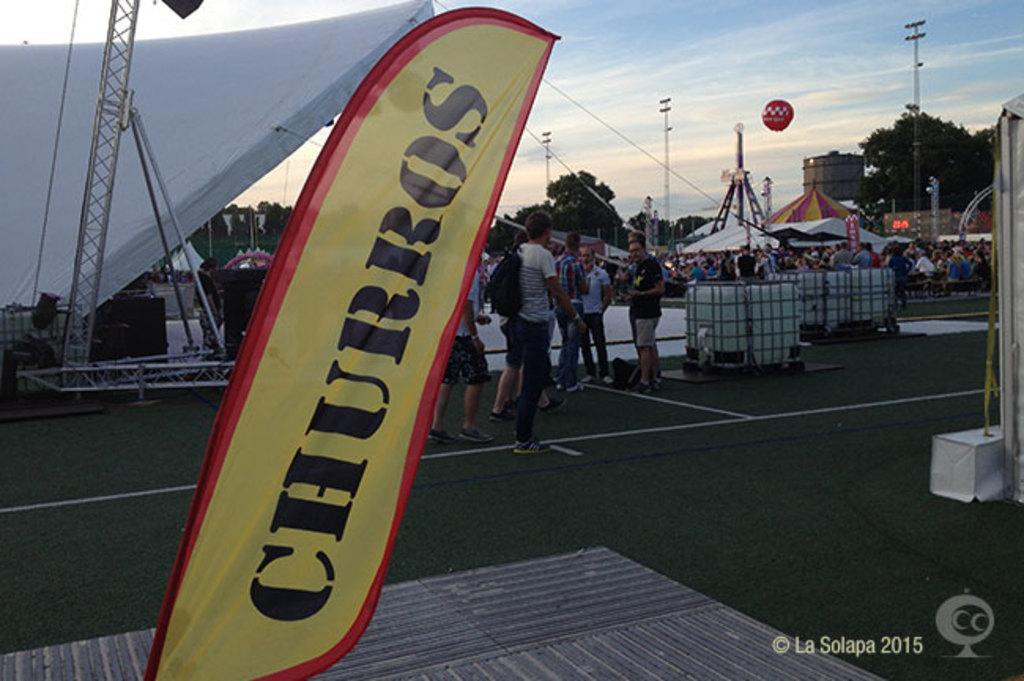Provide a one-sentence caption for the provided image. A yellow sign at a carnival is advertising churros. 